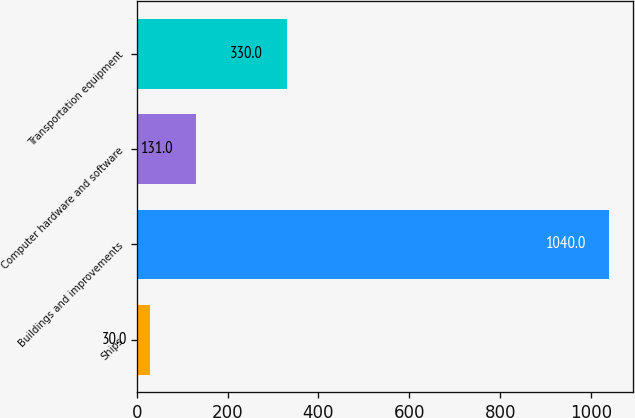Convert chart. <chart><loc_0><loc_0><loc_500><loc_500><bar_chart><fcel>Ships<fcel>Buildings and improvements<fcel>Computer hardware and software<fcel>Transportation equipment<nl><fcel>30<fcel>1040<fcel>131<fcel>330<nl></chart> 